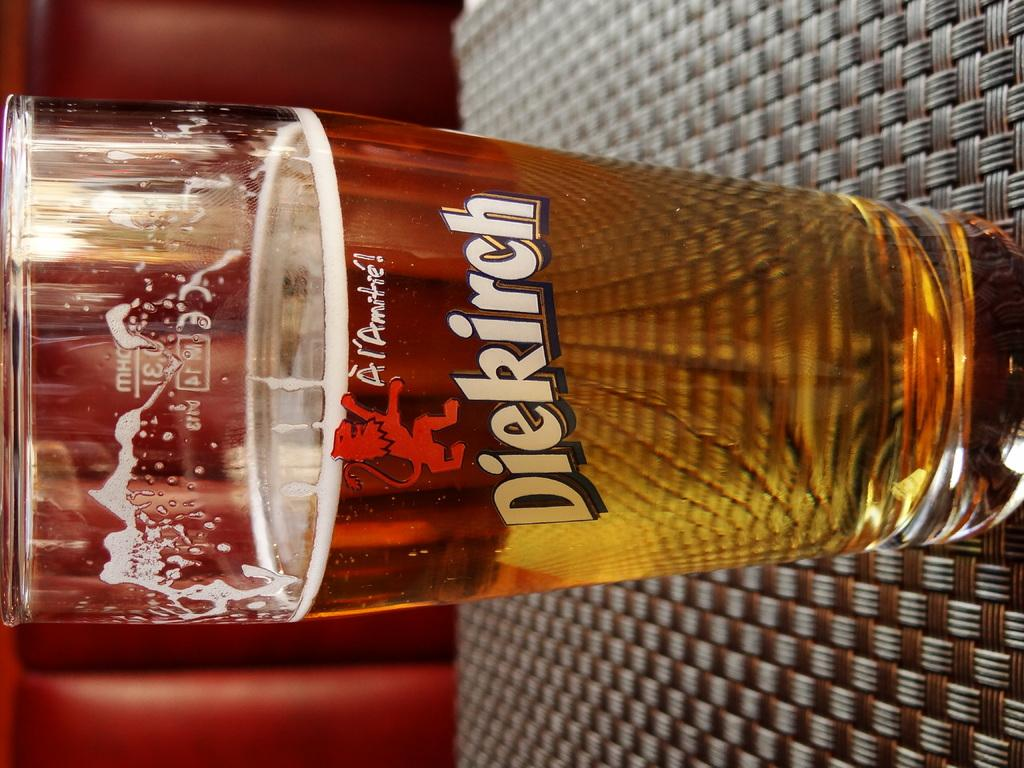<image>
Share a concise interpretation of the image provided. a glass on a table holding diekirch beer 